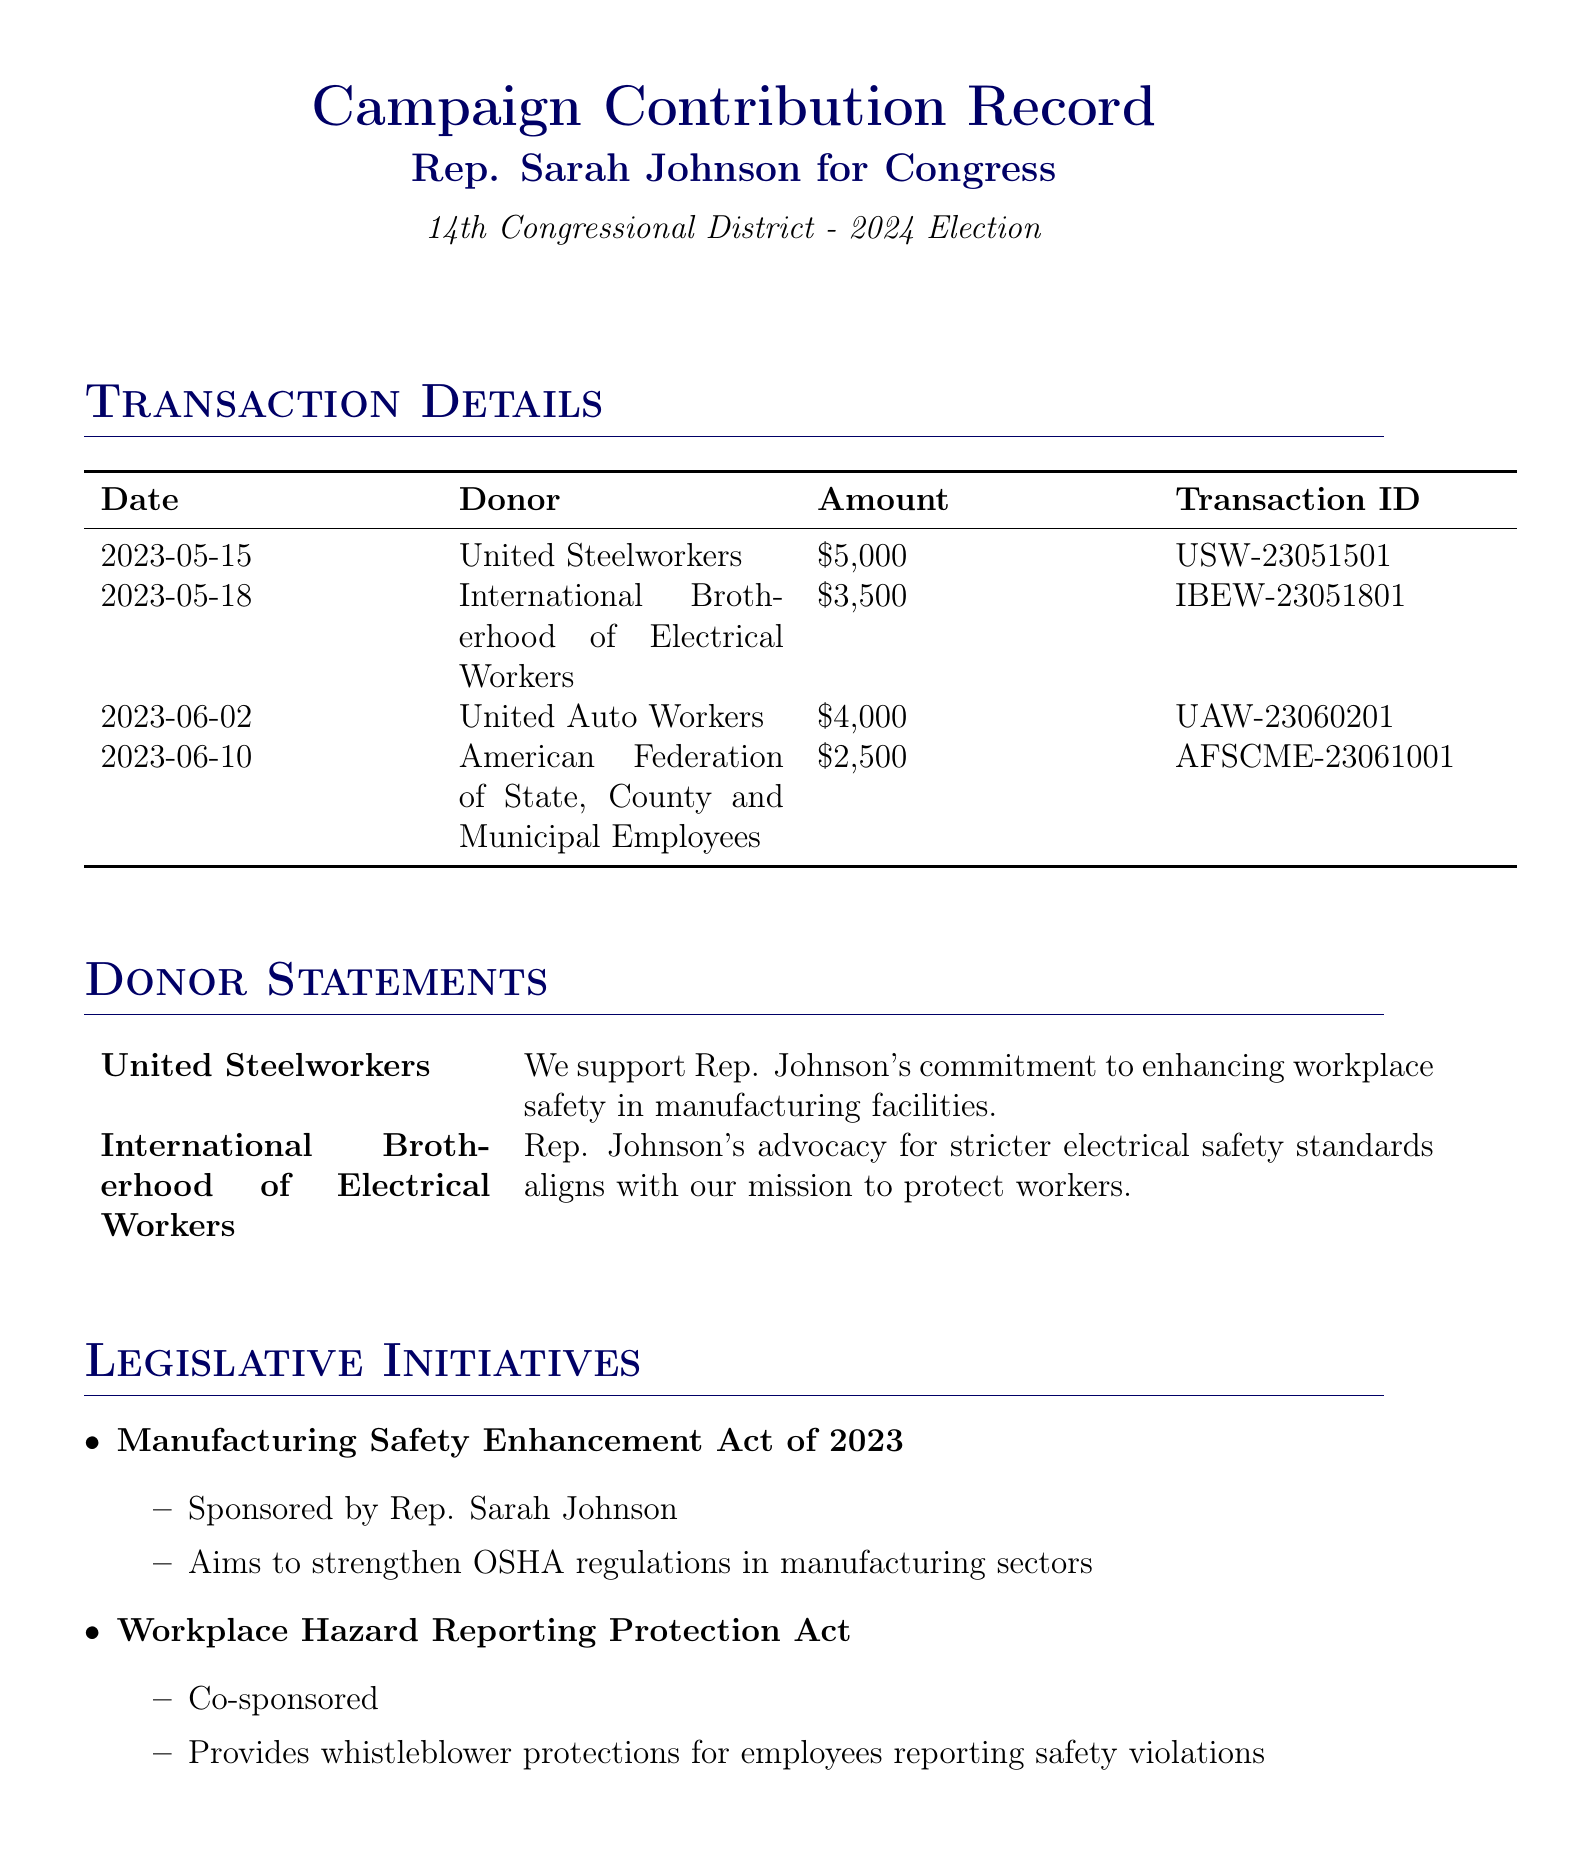What is the date of the first transaction? The first transaction date is found in the transaction details section.
Answer: 2023-05-15 Who made a contribution of $4,000? This contribution amount can be found in the transaction details.
Answer: United Auto Workers What is the total amount contributed by labor unions in this document? The total amount is the sum of all contributions listed in the transaction details.
Answer: $16,000 Which donor supports enhanced workplace safety in manufacturing? This information is stated in the donor statements section.
Answer: United Steelworkers What bill is sponsored by Rep. Sarah Johnson? The title of the bill sponsored by her is found in the legislative initiatives section.
Answer: Manufacturing Safety Enhancement Act of 2023 How many campaign pledges are listed? The count of pledges can be determined from the campaign pledges section.
Answer: 3 What is the focus of workplace safety regulations mentioned? This is a straightforward retrieval question regarding the specific focus areas listed.
Answer: Improved machine guarding requirements Is the 'Workplace Hazard Reporting Protection Act' co-sponsored? This information can be found in the legislative initiatives section.
Answer: Yes 